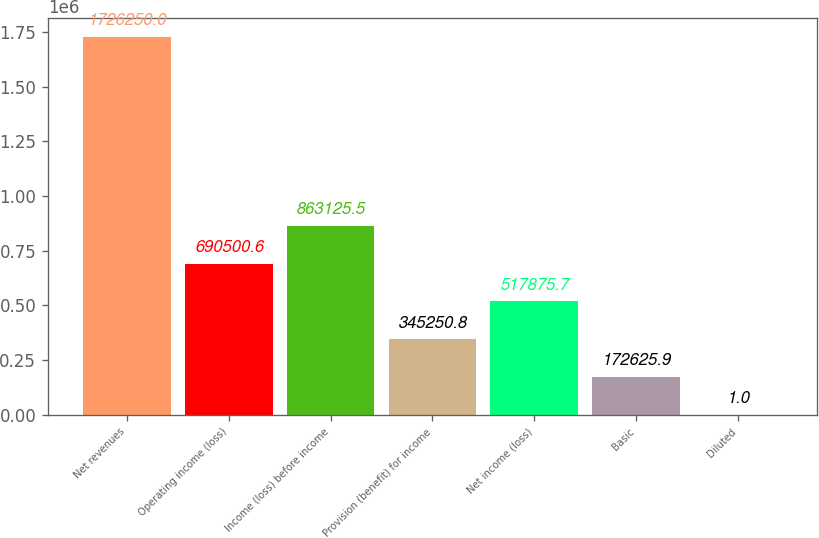Convert chart to OTSL. <chart><loc_0><loc_0><loc_500><loc_500><bar_chart><fcel>Net revenues<fcel>Operating income (loss)<fcel>Income (loss) before income<fcel>Provision (benefit) for income<fcel>Net income (loss)<fcel>Basic<fcel>Diluted<nl><fcel>1.72625e+06<fcel>690501<fcel>863126<fcel>345251<fcel>517876<fcel>172626<fcel>1<nl></chart> 